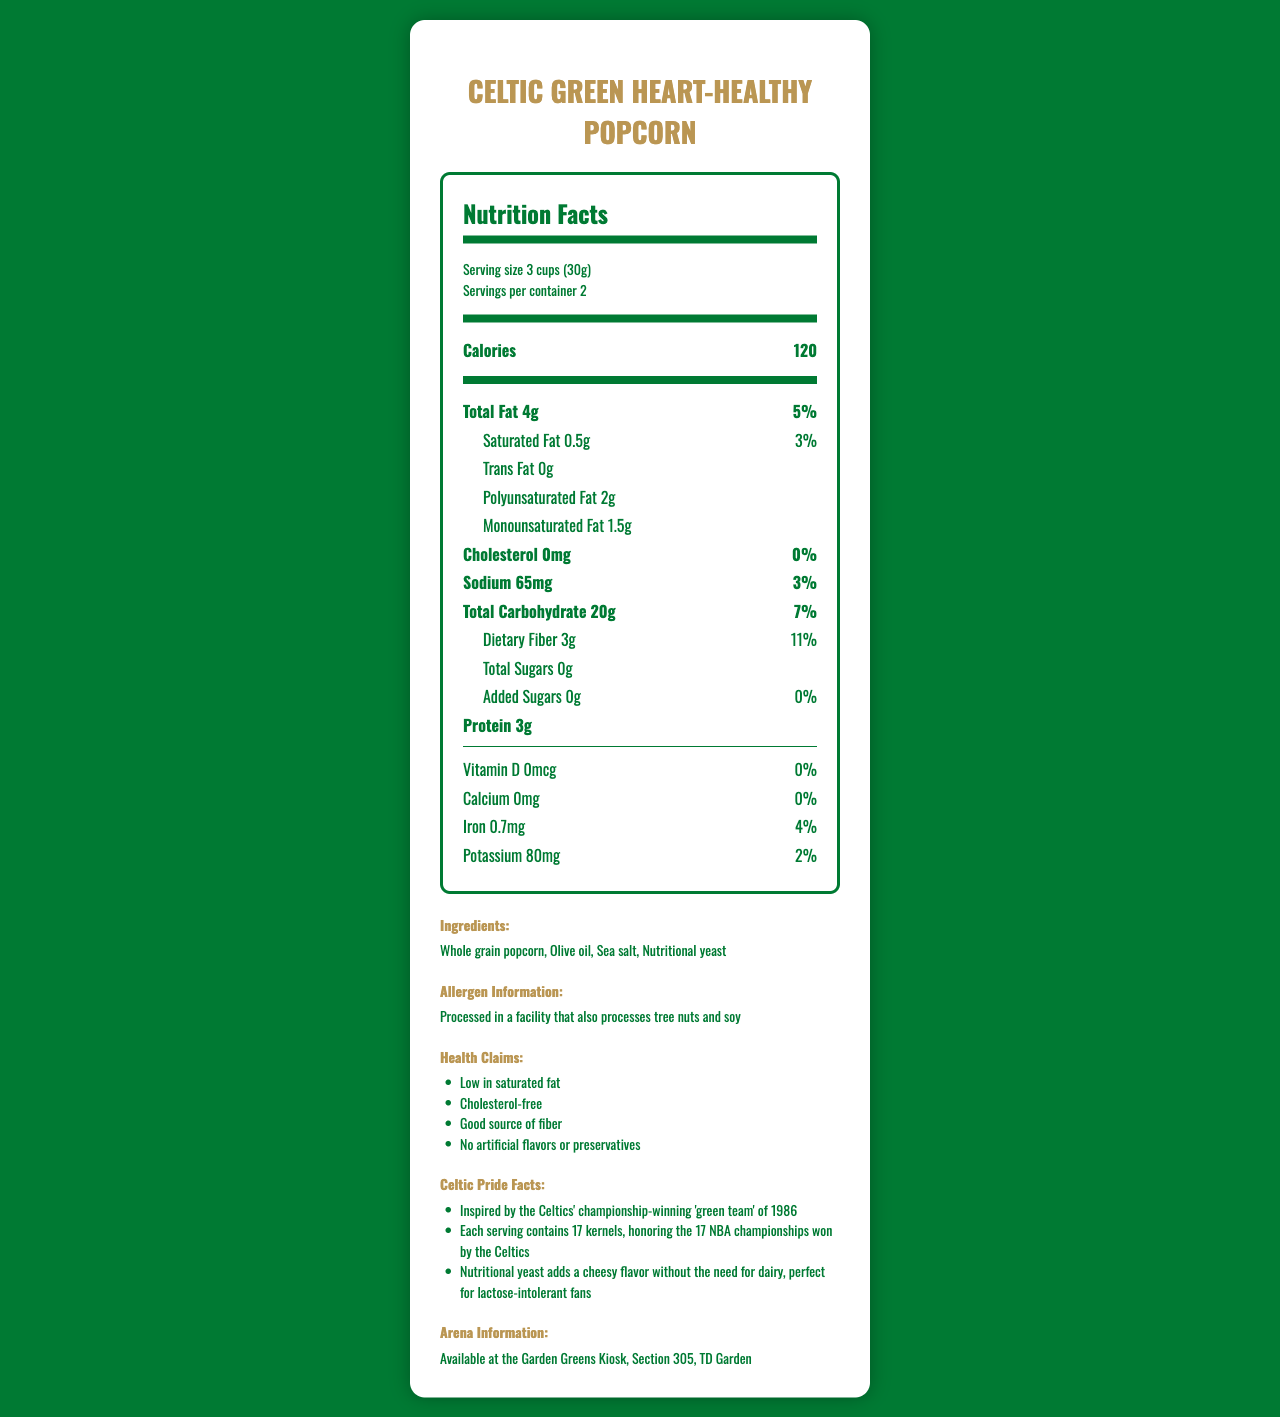What is the serving size for Celtic Green Heart-Healthy Popcorn? The serving size is listed as "Serving size 3 cups (30g)" in the serving info section of the document.
Answer: 3 cups (30g) How many calories are there per serving? The calories per serving are listed as 120 in the nutrient row section for calories.
Answer: 120 What is the total fat content and its percent daily value per serving? The total fat content per serving is 4g with a percent daily value of 5%, as shown in the document's total fat row.
Answer: 4g, 5% How much dietary fiber is in one serving? The dietary fiber content per serving is listed as 3g in the nutrient row for dietary fiber.
Answer: 3g Which ingredient is used to add a cheesy flavor without using dairy? The ingredient noted to add a cheesy flavor without dairy is nutritional yeast, mentioned in the Celtic Pride Facts section.
Answer: Nutritional yeast What is the percent daily value of iron per serving? The percent daily value of iron per serving is listed as 4% in the nutrients section under iron.
Answer: 4% How many servings are there per container? The number of servings per container is listed as 2 in the serving info section.
Answer: 2 Are there any artificial flavors or preservatives in the product? The product has "No artificial flavors or preservatives" as stated in the health claims section.
Answer: No Where can I find this product at the TD Garden? The arena information section specifies that the product is available at the Garden Greens Kiosk, Section 305.
Answer: Garden Greens Kiosk, Section 305 What is the amount of sodium in one serving? The sodium content per serving is listed as 65mg in the nutrients section.
Answer: 65mg Which of the following is NOT an ingredient in this popcorn?
A. Whole grain popcorn
B. Olive oil
C. Butter
D. Sea salt The ingredients listed are Whole grain popcorn, Olive oil, Sea salt, and Nutritional yeast. Butter is not listed.
Answer: C. Butter A. I and II
B. I and III
C. II and IV
D. III and IV The health claims listed in the document are Low in saturated fat and Good source of fiber. Therefore, I and III are correct.
Answer: B. I and III Is there any cholesterol in this popcorn? The cholesterol content per serving is listed as 0mg with a percent daily value of 0%, indicating that there is no cholesterol.
Answer: No Summarize the main features of Celtic Green Heart-Healthy Popcorn. The document provides detailed nutritional information for each serving size, ingredients used, allergen information, and noteworthy health claims. It draws a unique connection to the Celtics’ history while emphasizing the product's health benefits and availability at the arena.
Answer: This popcorn is branded as Celtic Green Heart-Healthy Popcorn and is available at the TD Garden's Garden Greens Kiosk in Section 305. It has health-conscious ingredients like whole grain popcorn, olive oil, sea salt, and nutritional yeast. Each serving is 3 cups (30g) with 120 calories, 4g of total fat, and 3g of dietary fiber. The product is low in saturated fat, cholesterol-free, and has no added sugars or artificial flavors. Special Celtic Pride facts highlight its connection to the Boston Celtics' legacy. How many grams of trans fat are in one serving? The amount of trans fat is given as 0g, but it is not stated if 0g means absolutely zero or a value small enough to be rounded down to zero. The exact amount cannot be determined based on the visual information.
Answer: Cannot be determined 